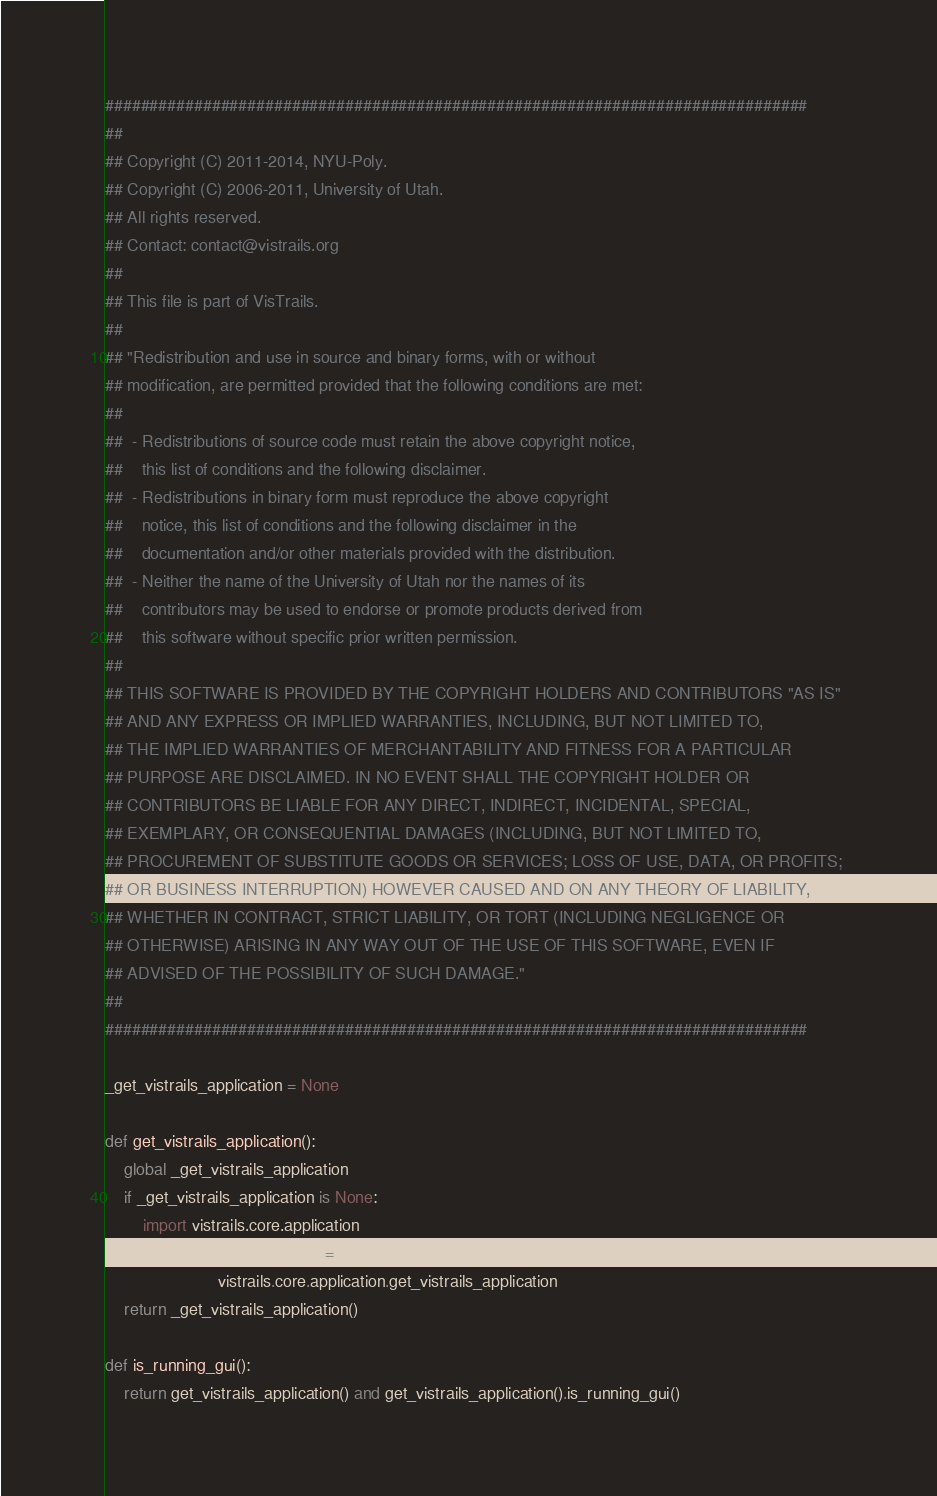<code> <loc_0><loc_0><loc_500><loc_500><_Python_>###############################################################################
##
## Copyright (C) 2011-2014, NYU-Poly.
## Copyright (C) 2006-2011, University of Utah. 
## All rights reserved.
## Contact: contact@vistrails.org
##
## This file is part of VisTrails.
##
## "Redistribution and use in source and binary forms, with or without 
## modification, are permitted provided that the following conditions are met:
##
##  - Redistributions of source code must retain the above copyright notice, 
##    this list of conditions and the following disclaimer.
##  - Redistributions in binary form must reproduce the above copyright 
##    notice, this list of conditions and the following disclaimer in the 
##    documentation and/or other materials provided with the distribution.
##  - Neither the name of the University of Utah nor the names of its 
##    contributors may be used to endorse or promote products derived from 
##    this software without specific prior written permission.
##
## THIS SOFTWARE IS PROVIDED BY THE COPYRIGHT HOLDERS AND CONTRIBUTORS "AS IS" 
## AND ANY EXPRESS OR IMPLIED WARRANTIES, INCLUDING, BUT NOT LIMITED TO, 
## THE IMPLIED WARRANTIES OF MERCHANTABILITY AND FITNESS FOR A PARTICULAR 
## PURPOSE ARE DISCLAIMED. IN NO EVENT SHALL THE COPYRIGHT HOLDER OR 
## CONTRIBUTORS BE LIABLE FOR ANY DIRECT, INDIRECT, INCIDENTAL, SPECIAL, 
## EXEMPLARY, OR CONSEQUENTIAL DAMAGES (INCLUDING, BUT NOT LIMITED TO, 
## PROCUREMENT OF SUBSTITUTE GOODS OR SERVICES; LOSS OF USE, DATA, OR PROFITS; 
## OR BUSINESS INTERRUPTION) HOWEVER CAUSED AND ON ANY THEORY OF LIABILITY, 
## WHETHER IN CONTRACT, STRICT LIABILITY, OR TORT (INCLUDING NEGLIGENCE OR 
## OTHERWISE) ARISING IN ANY WAY OUT OF THE USE OF THIS SOFTWARE, EVEN IF 
## ADVISED OF THE POSSIBILITY OF SUCH DAMAGE."
##
###############################################################################

_get_vistrails_application = None

def get_vistrails_application():
    global _get_vistrails_application
    if _get_vistrails_application is None:
        import vistrails.core.application
        _get_vistrails_application = \
                        vistrails.core.application.get_vistrails_application
    return _get_vistrails_application()

def is_running_gui():
    return get_vistrails_application() and get_vistrails_application().is_running_gui()
</code> 